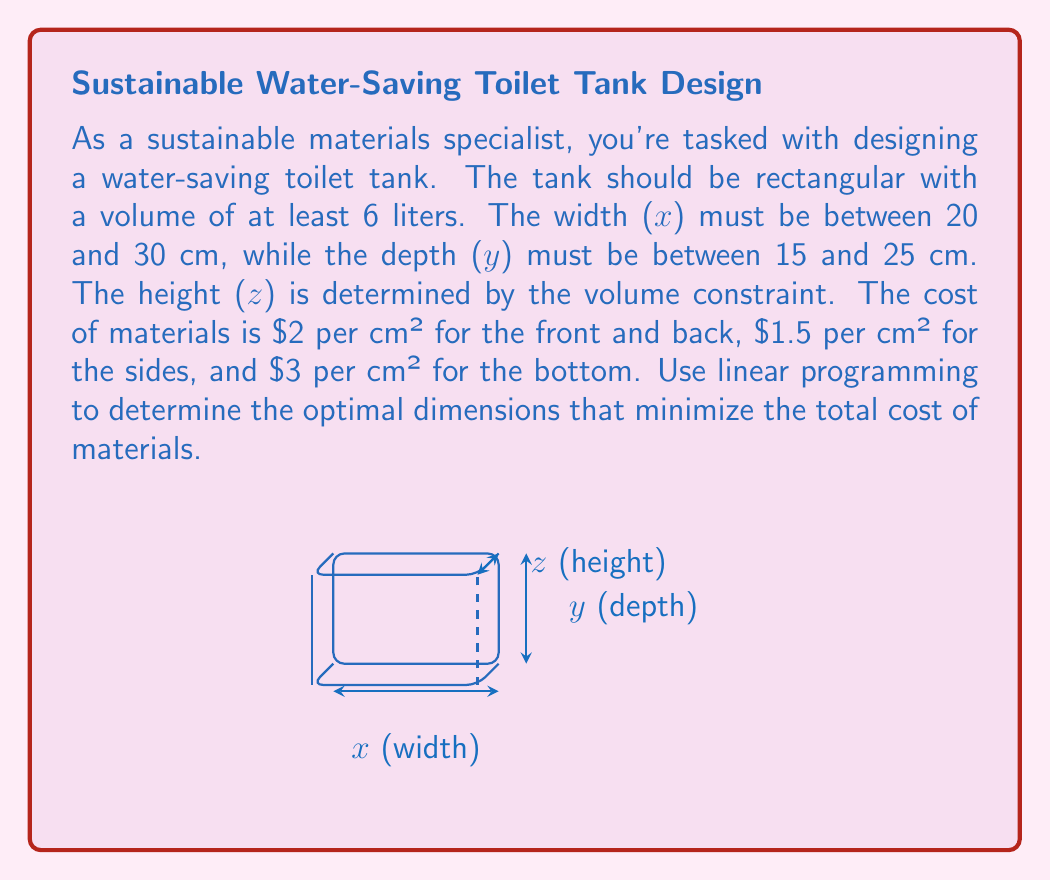Teach me how to tackle this problem. Let's approach this step-by-step:

1) First, we need to set up our objective function. The total cost is:
   $$2(xz + yz) + 1.5(2xy) + 3xy$$
   Simplifying: $$2xz + 2yz + 3xy + 3xy = 2xz + 2yz + 6xy$$

2) Our constraints are:
   - Volume: $xyz \geq 6000$ cm³ (converting 6 liters to cm³)
   - Width: $20 \leq x \leq 30$
   - Depth: $15 \leq y \leq 25$

3) We can simplify the volume constraint by noting that $z = \frac{6000}{xy}$

4) Substituting this into our objective function:
   $$2x(\frac{6000}{xy}) + 2y(\frac{6000}{xy}) + 6xy$$
   $$= \frac{12000}{y} + \frac{12000}{x} + 6xy$$

5) Now we have a nonlinear optimization problem. To solve this with linear programming, we need to linearize it. One way to do this is to consider discrete values for x and y within their ranges.

6) Let's create a grid of possible (x,y) values:
   x: 20, 22, 24, 26, 28, 30
   y: 15, 17, 19, 21, 23, 25

7) For each (x,y) pair, we calculate z and the total cost:

   For example, when x = 20 and y = 15:
   z = 6000 / (20 * 15) = 20
   Cost = (12000/15) + (12000/20) + 6*20*15 = 3600

8) After calculating for all pairs, we find the minimum cost.
Answer: x = 30 cm, y = 25 cm, z = 8 cm, Total cost = $3180 